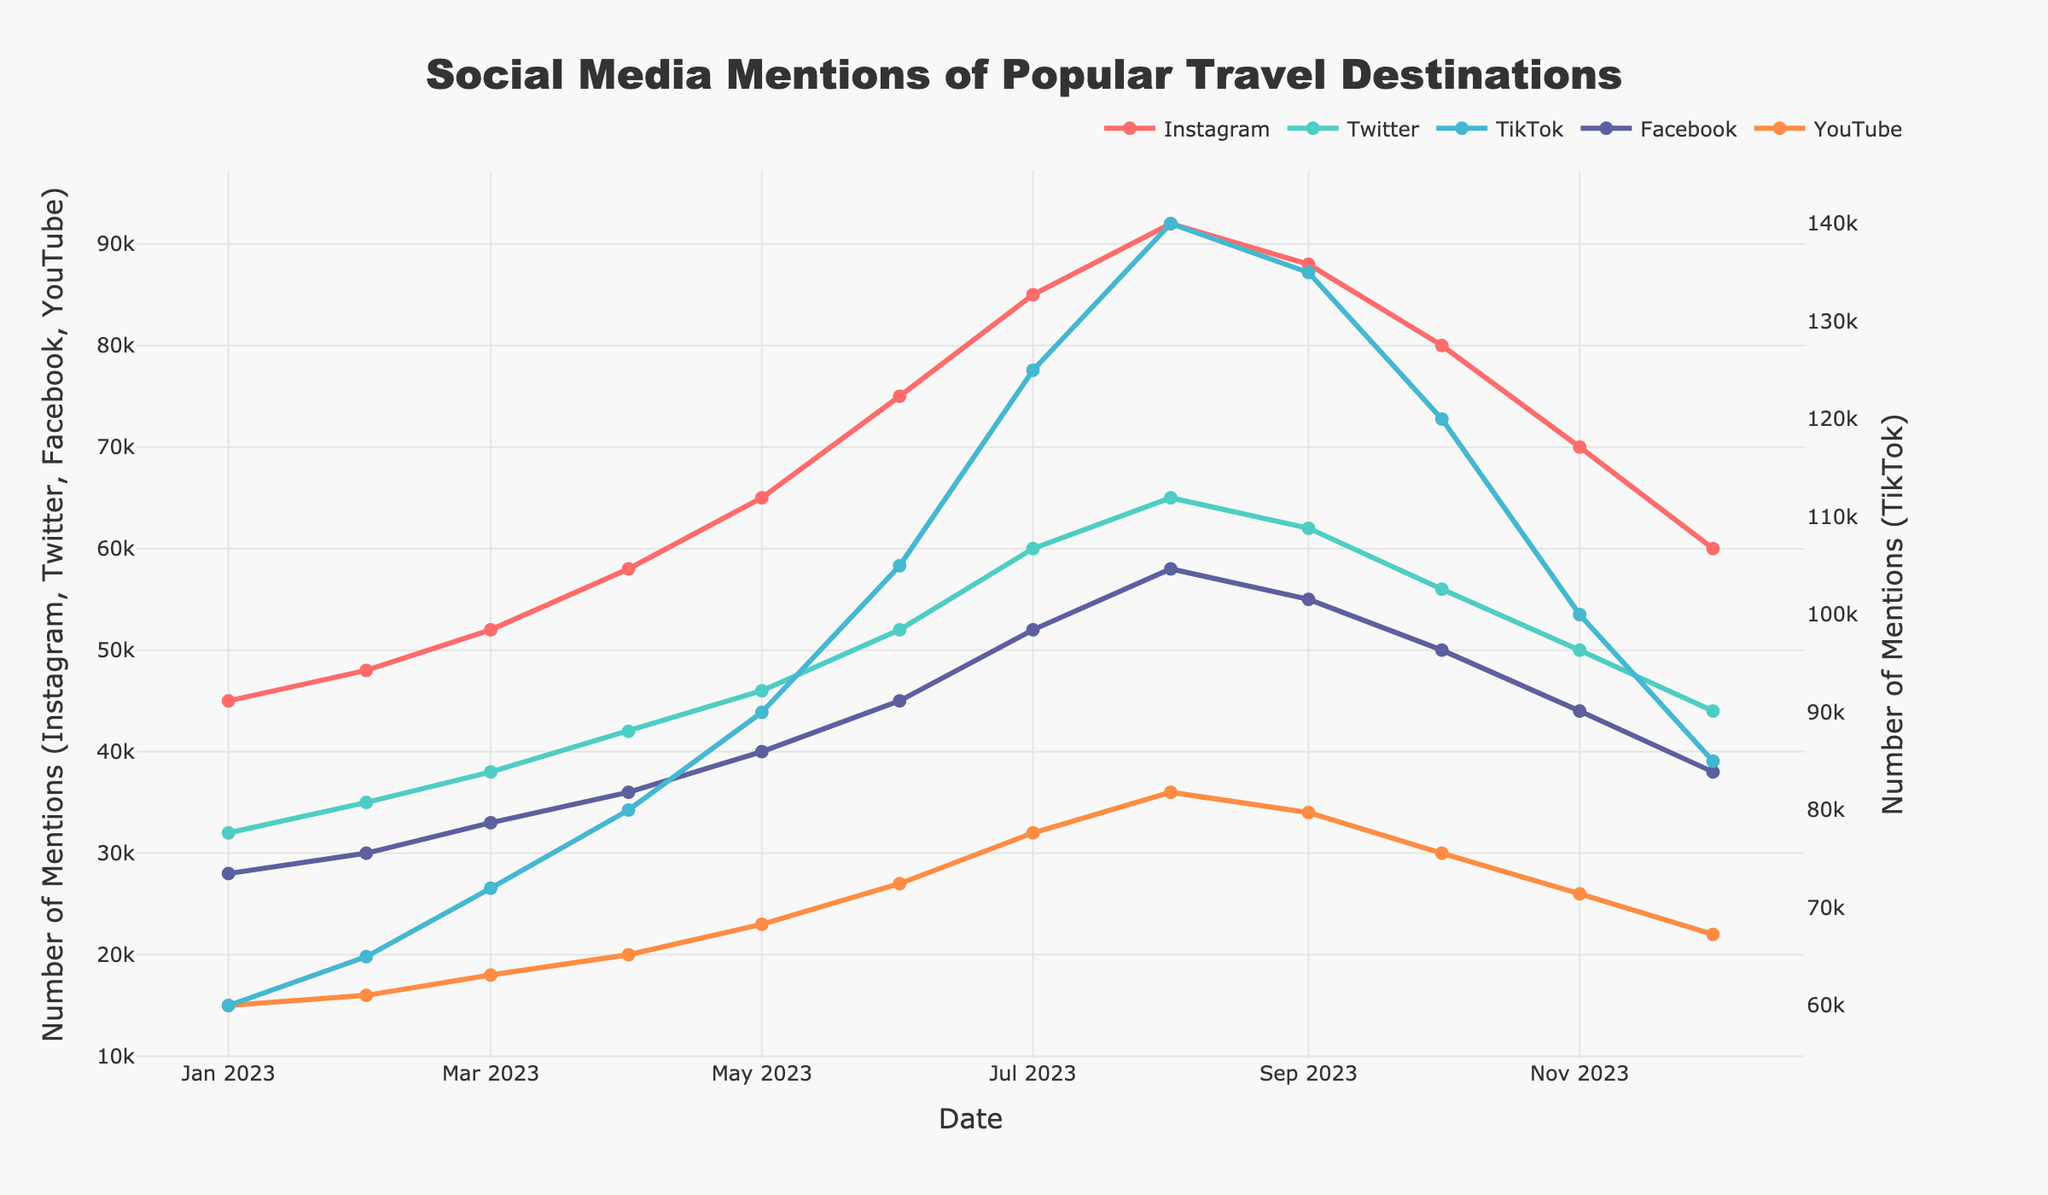What is the trend of Instagram mentions from January to December? The Instagram mentions are consistently increasing from January to July, peaking in August at 92,000, and then start to decline gradually from September to December.
Answer: Increasing until August, then decreasing Which platform had the highest number of mentions in July? TikTok had the highest number of mentions in July. By observing the peaks across all platforms, TikTok had the most with 125,000 mentions in July.
Answer: TikTok What is the difference in YouTube mentions from January to December? By subtracting the number of mentions in December (22,000) from January (15,000), the difference is 22,000 - 15,000 = 7,000.
Answer: 7,000 Between February and June, which platform showed the greatest increase in mentions? To find the greatest increase, subtract the February values from the June values for each platform and compare the results. TikTok had the highest increase: 105,000 - 65,000 = 40,000.
Answer: TikTok Which month shows the peak mentions for Facebook? The peak for Facebook is observed in August with 58,000 mentions, as indicated by the highest point in the Facebook line.
Answer: August How do the trends for Instagram and TikTok compare throughout the year? Both Instagram and TikTok show an overall increasing trend in mentions until around August. However, TikTok experiences a sharper rise and a higher peak and then declines more significantly towards the end of the year.
Answer: Similar upward trend until August, TikTok rises and falls more sharply What is the cumulative total of Twitter mentions from January to December? Sum up all the monthly mentions for Twitter: 32,000 + 35,000 + 38,000 + 42,000 + 46,000 + 52,000 + 60,000 + 65,000 + 62,000 + 56,000 + 50,000 + 44,000 = 582,000.
Answer: 582,000 Which two platforms had almost equal mentions in December? In December, Twitter (44,000) and Instagram (60,000) seem almost equal in their mentions compared to their other monthly figures, as visually the markers sit close on the y-axis scale.
Answer: Twitter and Instagram What is the average number of mentions for Facebook across the year? Calculate the sum of all Facebook mentions and divide by the number of months: (28,000 + 30,000 + 33,000 + 36,000 + 40,000 + 45,000 + 52,000 + 58,000 + 55,000 + 50,000 + 44,000 + 38,000) / 12 = 43,250.
Answer: 43,250 Comparing the month of September, which platform has the fewest number of mentions? In September, YouTube has the fewest mentions with 34,000, as seen by the lowest point among the plotted values for that month.
Answer: YouTube 